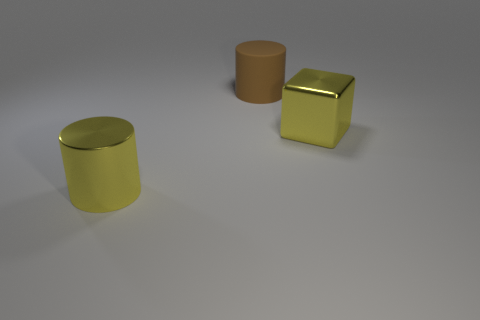There is a metallic thing right of the large metal thing that is left of the shiny thing that is right of the matte cylinder; what color is it?
Give a very brief answer. Yellow. Is there anything else that has the same color as the big matte object?
Provide a short and direct response. No. How many other things are there of the same material as the large brown thing?
Offer a very short reply. 0. How big is the yellow shiny block?
Your response must be concise. Large. Are there any large gray metal things of the same shape as the large brown rubber object?
Your answer should be very brief. No. What number of things are either yellow metal objects or yellow objects that are left of the brown cylinder?
Your answer should be compact. 2. The metal thing on the right side of the shiny cylinder is what color?
Provide a short and direct response. Yellow. Is the size of the object left of the large brown rubber object the same as the object that is to the right of the large brown cylinder?
Offer a terse response. Yes. Are there any cylinders that have the same size as the yellow block?
Provide a succinct answer. Yes. There is a cylinder that is in front of the brown cylinder; how many brown objects are in front of it?
Provide a succinct answer. 0. 